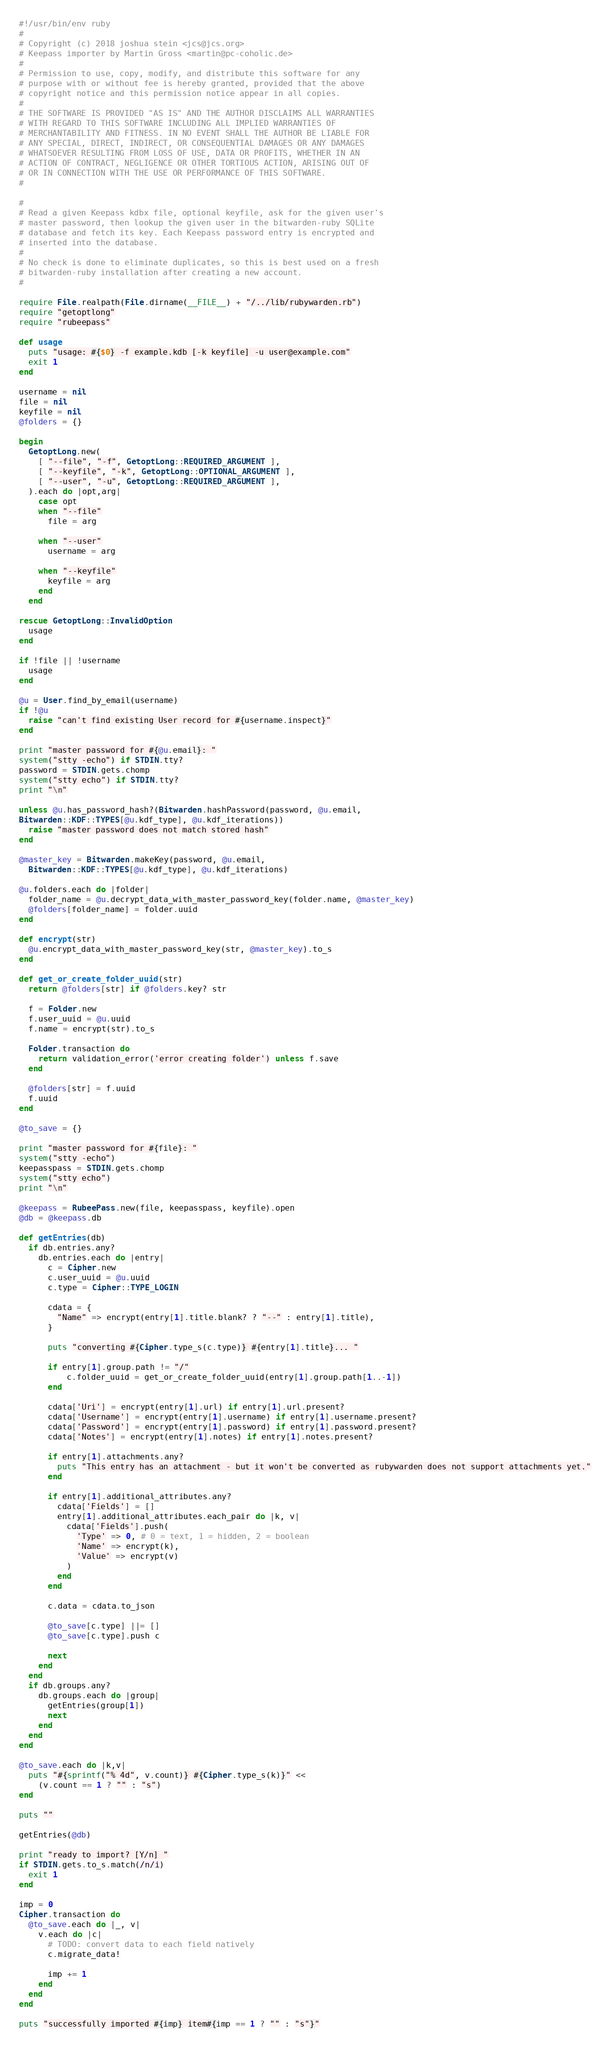<code> <loc_0><loc_0><loc_500><loc_500><_Ruby_>#!/usr/bin/env ruby
#
# Copyright (c) 2018 joshua stein <jcs@jcs.org>
# Keepass importer by Martin Gross <martin@pc-coholic.de>
#
# Permission to use, copy, modify, and distribute this software for any
# purpose with or without fee is hereby granted, provided that the above
# copyright notice and this permission notice appear in all copies.
#
# THE SOFTWARE IS PROVIDED "AS IS" AND THE AUTHOR DISCLAIMS ALL WARRANTIES
# WITH REGARD TO THIS SOFTWARE INCLUDING ALL IMPLIED WARRANTIES OF
# MERCHANTABILITY AND FITNESS. IN NO EVENT SHALL THE AUTHOR BE LIABLE FOR
# ANY SPECIAL, DIRECT, INDIRECT, OR CONSEQUENTIAL DAMAGES OR ANY DAMAGES
# WHATSOEVER RESULTING FROM LOSS OF USE, DATA OR PROFITS, WHETHER IN AN
# ACTION OF CONTRACT, NEGLIGENCE OR OTHER TORTIOUS ACTION, ARISING OUT OF
# OR IN CONNECTION WITH THE USE OR PERFORMANCE OF THIS SOFTWARE.
#

#
# Read a given Keepass kdbx file, optional keyfile, ask for the given user's
# master password, then lookup the given user in the bitwarden-ruby SQLite
# database and fetch its key. Each Keepass password entry is encrypted and
# inserted into the database.
#
# No check is done to eliminate duplicates, so this is best used on a fresh
# bitwarden-ruby installation after creating a new account.
#

require File.realpath(File.dirname(__FILE__) + "/../lib/rubywarden.rb")
require "getoptlong"
require "rubeepass"

def usage
  puts "usage: #{$0} -f example.kdb [-k keyfile] -u user@example.com"
  exit 1
end

username = nil
file = nil
keyfile = nil
@folders = {}

begin
  GetoptLong.new(
    [ "--file", "-f", GetoptLong::REQUIRED_ARGUMENT ],
    [ "--keyfile", "-k", GetoptLong::OPTIONAL_ARGUMENT ],
    [ "--user", "-u", GetoptLong::REQUIRED_ARGUMENT ],
  ).each do |opt,arg|
    case opt
    when "--file"
      file = arg

    when "--user"
      username = arg

    when "--keyfile"
      keyfile = arg
    end
  end

rescue GetoptLong::InvalidOption
  usage
end

if !file || !username
  usage
end

@u = User.find_by_email(username)
if !@u
  raise "can't find existing User record for #{username.inspect}"
end

print "master password for #{@u.email}: "
system("stty -echo") if STDIN.tty?
password = STDIN.gets.chomp
system("stty echo") if STDIN.tty?
print "\n"

unless @u.has_password_hash?(Bitwarden.hashPassword(password, @u.email,
Bitwarden::KDF::TYPES[@u.kdf_type], @u.kdf_iterations))
  raise "master password does not match stored hash"
end

@master_key = Bitwarden.makeKey(password, @u.email,
  Bitwarden::KDF::TYPES[@u.kdf_type], @u.kdf_iterations)

@u.folders.each do |folder|
  folder_name = @u.decrypt_data_with_master_password_key(folder.name, @master_key)
  @folders[folder_name] = folder.uuid
end

def encrypt(str)
  @u.encrypt_data_with_master_password_key(str, @master_key).to_s
end

def get_or_create_folder_uuid(str)
  return @folders[str] if @folders.key? str

  f = Folder.new
  f.user_uuid = @u.uuid
  f.name = encrypt(str).to_s

  Folder.transaction do
    return validation_error('error creating folder') unless f.save
  end

  @folders[str] = f.uuid
  f.uuid
end

@to_save = {}

print "master password for #{file}: "
system("stty -echo")
keepasspass = STDIN.gets.chomp
system("stty echo")
print "\n"

@keepass = RubeePass.new(file, keepasspass, keyfile).open
@db = @keepass.db

def getEntries(db)
  if db.entries.any?
    db.entries.each do |entry|
      c = Cipher.new
      c.user_uuid = @u.uuid
      c.type = Cipher::TYPE_LOGIN

      cdata = {
        "Name" => encrypt(entry[1].title.blank? ? "--" : entry[1].title),
      }

      puts "converting #{Cipher.type_s(c.type)} #{entry[1].title}... "

      if entry[1].group.path != "/"
          c.folder_uuid = get_or_create_folder_uuid(entry[1].group.path[1..-1])
      end

      cdata['Uri'] = encrypt(entry[1].url) if entry[1].url.present?
      cdata['Username'] = encrypt(entry[1].username) if entry[1].username.present?
      cdata['Password'] = encrypt(entry[1].password) if entry[1].password.present?
      cdata['Notes'] = encrypt(entry[1].notes) if entry[1].notes.present?

      if entry[1].attachments.any?
        puts "This entry has an attachment - but it won't be converted as rubywarden does not support attachments yet."
      end

      if entry[1].additional_attributes.any?
        cdata['Fields'] = []
        entry[1].additional_attributes.each_pair do |k, v|
          cdata['Fields'].push(
            'Type' => 0, # 0 = text, 1 = hidden, 2 = boolean
            'Name' => encrypt(k),
            'Value' => encrypt(v)
          )
        end
      end

      c.data = cdata.to_json

      @to_save[c.type] ||= []
      @to_save[c.type].push c

      next
    end
  end
  if db.groups.any?
    db.groups.each do |group|
      getEntries(group[1])
      next
    end
  end
end

@to_save.each do |k,v|
  puts "#{sprintf("% 4d", v.count)} #{Cipher.type_s(k)}" <<
    (v.count == 1 ? "" : "s")
end

puts ""

getEntries(@db)

print "ready to import? [Y/n] "
if STDIN.gets.to_s.match(/n/i)
  exit 1
end

imp = 0
Cipher.transaction do
  @to_save.each do |_, v|
    v.each do |c|
      # TODO: convert data to each field natively
      c.migrate_data!

      imp += 1
    end
  end
end

puts "successfully imported #{imp} item#{imp == 1 ? "" : "s"}"
</code> 